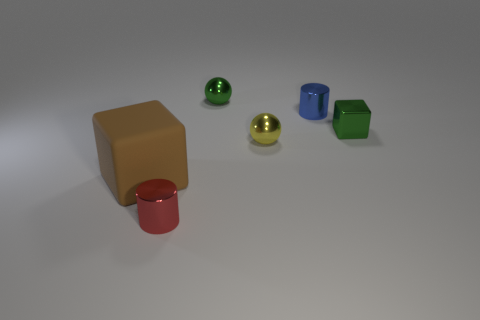Is there anything else that is the same material as the large cube?
Offer a terse response. No. How many cyan objects are either small metal spheres or big objects?
Your answer should be compact. 0. There is a big cube to the left of the blue cylinder; what material is it?
Make the answer very short. Rubber. Is the number of tiny green shiny things greater than the number of tiny metallic things?
Your answer should be very brief. No. Do the small green metallic thing behind the small blue metallic cylinder and the yellow metal thing have the same shape?
Provide a succinct answer. Yes. How many small cylinders are right of the red metal cylinder and in front of the small green metallic block?
Ensure brevity in your answer.  0. What number of other small red objects are the same shape as the red metallic thing?
Offer a terse response. 0. What is the color of the block that is on the right side of the rubber thing left of the tiny yellow shiny object?
Offer a very short reply. Green. There is a big rubber object; is it the same shape as the tiny green shiny thing in front of the blue shiny cylinder?
Your response must be concise. Yes. What is the material of the cube that is to the left of the small cylinder on the right side of the small object that is in front of the brown thing?
Give a very brief answer. Rubber. 